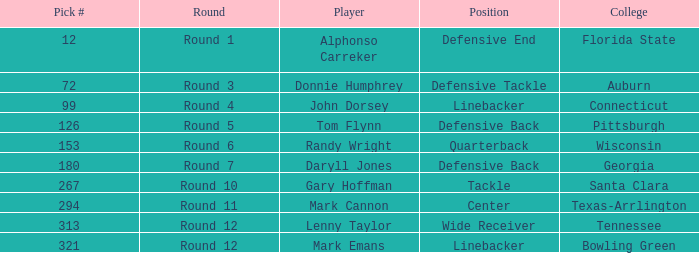In which round was an athlete from college of connecticut drafted? Round 4. 